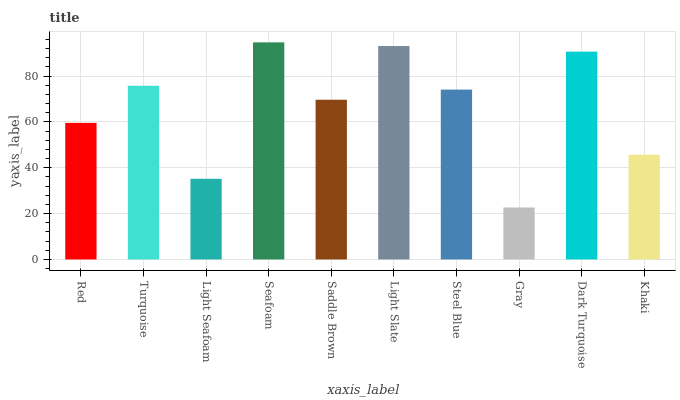Is Gray the minimum?
Answer yes or no. Yes. Is Seafoam the maximum?
Answer yes or no. Yes. Is Turquoise the minimum?
Answer yes or no. No. Is Turquoise the maximum?
Answer yes or no. No. Is Turquoise greater than Red?
Answer yes or no. Yes. Is Red less than Turquoise?
Answer yes or no. Yes. Is Red greater than Turquoise?
Answer yes or no. No. Is Turquoise less than Red?
Answer yes or no. No. Is Steel Blue the high median?
Answer yes or no. Yes. Is Saddle Brown the low median?
Answer yes or no. Yes. Is Khaki the high median?
Answer yes or no. No. Is Seafoam the low median?
Answer yes or no. No. 